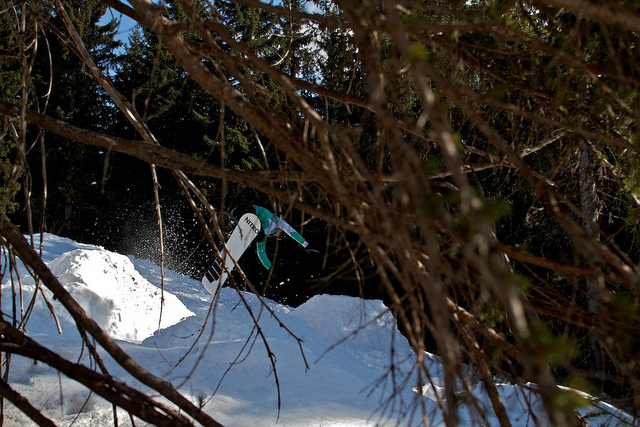Read all the text in this image. NITRO 